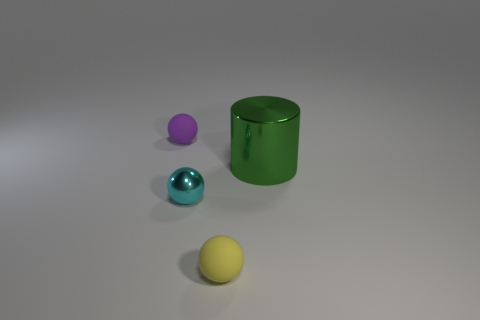Is the material of the big green object the same as the tiny yellow ball?
Ensure brevity in your answer.  No. The cyan object has what shape?
Offer a terse response. Sphere. How many big metallic objects are in front of the tiny matte object right of the tiny object behind the green metallic cylinder?
Offer a terse response. 0. What color is the other tiny matte thing that is the same shape as the yellow object?
Offer a terse response. Purple. There is a tiny matte thing in front of the large thing right of the tiny matte object on the left side of the yellow matte object; what is its shape?
Provide a short and direct response. Sphere. There is a thing that is to the left of the cylinder and on the right side of the tiny metal sphere; what is its size?
Your answer should be very brief. Small. Is the number of green shiny cubes less than the number of matte spheres?
Give a very brief answer. Yes. What size is the metallic thing on the right side of the tiny shiny sphere?
Your response must be concise. Large. There is a object that is both behind the cyan metal sphere and to the left of the green cylinder; what is its shape?
Provide a short and direct response. Sphere. How many other objects have the same material as the purple object?
Keep it short and to the point. 1. 